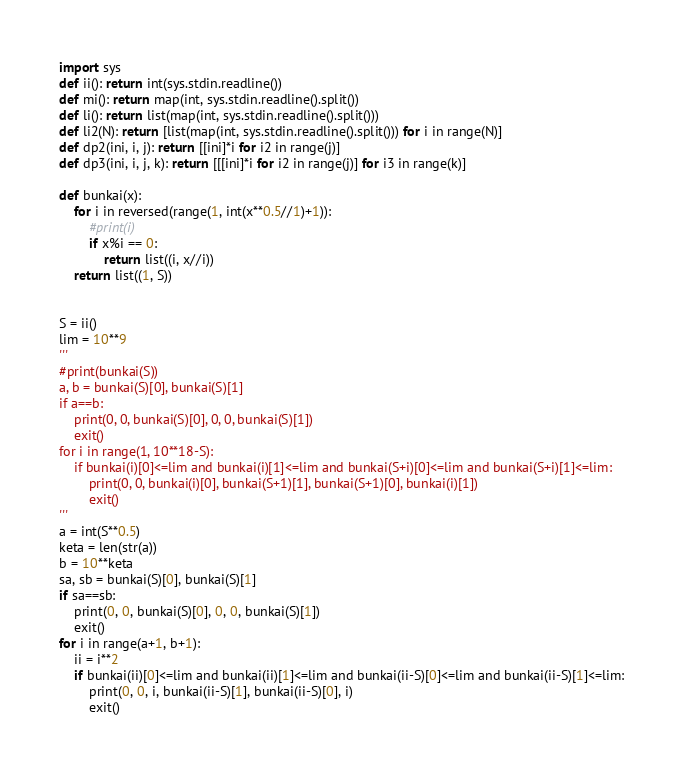Convert code to text. <code><loc_0><loc_0><loc_500><loc_500><_Python_>import sys
def ii(): return int(sys.stdin.readline())
def mi(): return map(int, sys.stdin.readline().split())
def li(): return list(map(int, sys.stdin.readline().split()))
def li2(N): return [list(map(int, sys.stdin.readline().split())) for i in range(N)]
def dp2(ini, i, j): return [[ini]*i for i2 in range(j)]
def dp3(ini, i, j, k): return [[[ini]*i for i2 in range(j)] for i3 in range(k)]

def bunkai(x):
    for i in reversed(range(1, int(x**0.5//1)+1)):
        #print(i)
        if x%i == 0:
            return list((i, x//i))
    return list((1, S))


S = ii()
lim = 10**9
'''
#print(bunkai(S))
a, b = bunkai(S)[0], bunkai(S)[1]
if a==b:
    print(0, 0, bunkai(S)[0], 0, 0, bunkai(S)[1])
    exit()
for i in range(1, 10**18-S):
    if bunkai(i)[0]<=lim and bunkai(i)[1]<=lim and bunkai(S+i)[0]<=lim and bunkai(S+i)[1]<=lim:
        print(0, 0, bunkai(i)[0], bunkai(S+1)[1], bunkai(S+1)[0], bunkai(i)[1])
        exit()
'''
a = int(S**0.5)
keta = len(str(a))
b = 10**keta
sa, sb = bunkai(S)[0], bunkai(S)[1]
if sa==sb:
    print(0, 0, bunkai(S)[0], 0, 0, bunkai(S)[1])
    exit()
for i in range(a+1, b+1):
    ii = i**2
    if bunkai(ii)[0]<=lim and bunkai(ii)[1]<=lim and bunkai(ii-S)[0]<=lim and bunkai(ii-S)[1]<=lim:
        print(0, 0, i, bunkai(ii-S)[1], bunkai(ii-S)[0], i)
        exit()</code> 